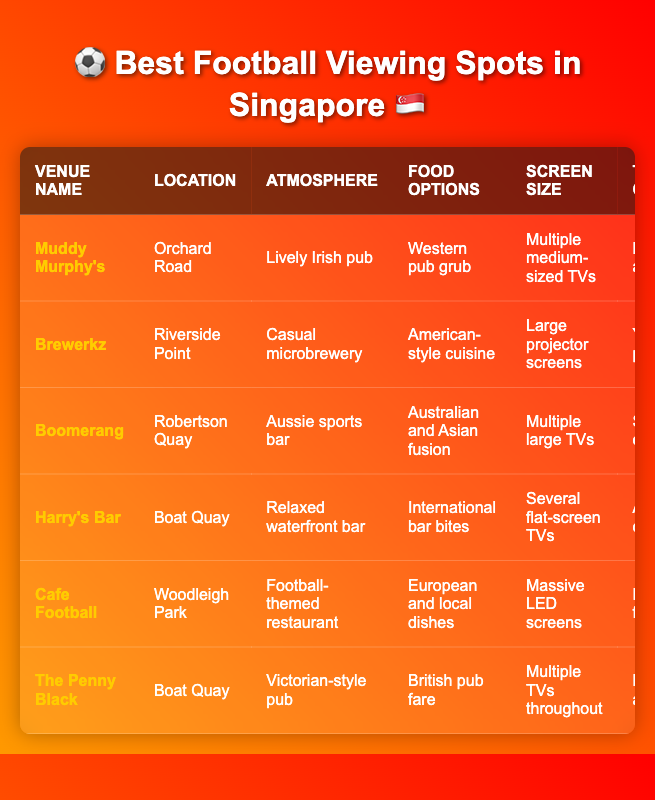What is the atmosphere at Muddy Murphy's? The table shows that Muddy Murphy's has a "Lively Irish pub" atmosphere
Answer: Lively Irish pub Which venue has the largest screen size? According to the table, Cafe Football features "Massive LED screens," which is the biggest screen size listed
Answer: Cafe Football Is Brewerkz located at Boat Quay? The table indicates that Brewerkz is located at Riverside Point, not Boat Quay
Answer: No What type of food options does Harry's Bar provide? The table specifies that Harry's Bar offers "International bar bites" as its food options
Answer: International bar bites How many venues have a mix of locals and tourists as their typical crowd? From the table, we see that The Penny Black has "Mix of locals and tourists," while Muddy Murphy's has "Mix of locals and expats," making a total of 2 venues with mixed crowds
Answer: 2 Which venue typically attracts young professionals? The table states that Brewerkz attracts "Young professionals," and no other venue is mentioned for this crowd type
Answer: Brewerkz What is the difference in atmosphere between Cafe Football and The Penny Black? Cafe Football has a "Football-themed restaurant" atmosphere, while The Penny Black has a "Victorian-style pub" atmosphere, showing a distinct theme difference
Answer: Different themes Which locations share venues? The table lists Brewerkz and Muddy Murphy's at different locations, while Harry's Bar and The Penny Black are both at Boat Quay
Answer: Boat Quay (Harry's Bar and The Penny Black) What food options are available at venues with a relaxed atmosphere? Both Harry's Bar and Boomerang have a relaxed atmosphere; Harry's Bar offers "International bar bites," and Boomerang provides "Australian and Asian fusion" options
Answer: Harry's Bar and Boomerang How many venues feature multiple TVs or screens? The venues with multiple screens include Muddy Murphy's, Boomerang, Harry's Bar, and The Penny Black, totaling 4 venues
Answer: 4 